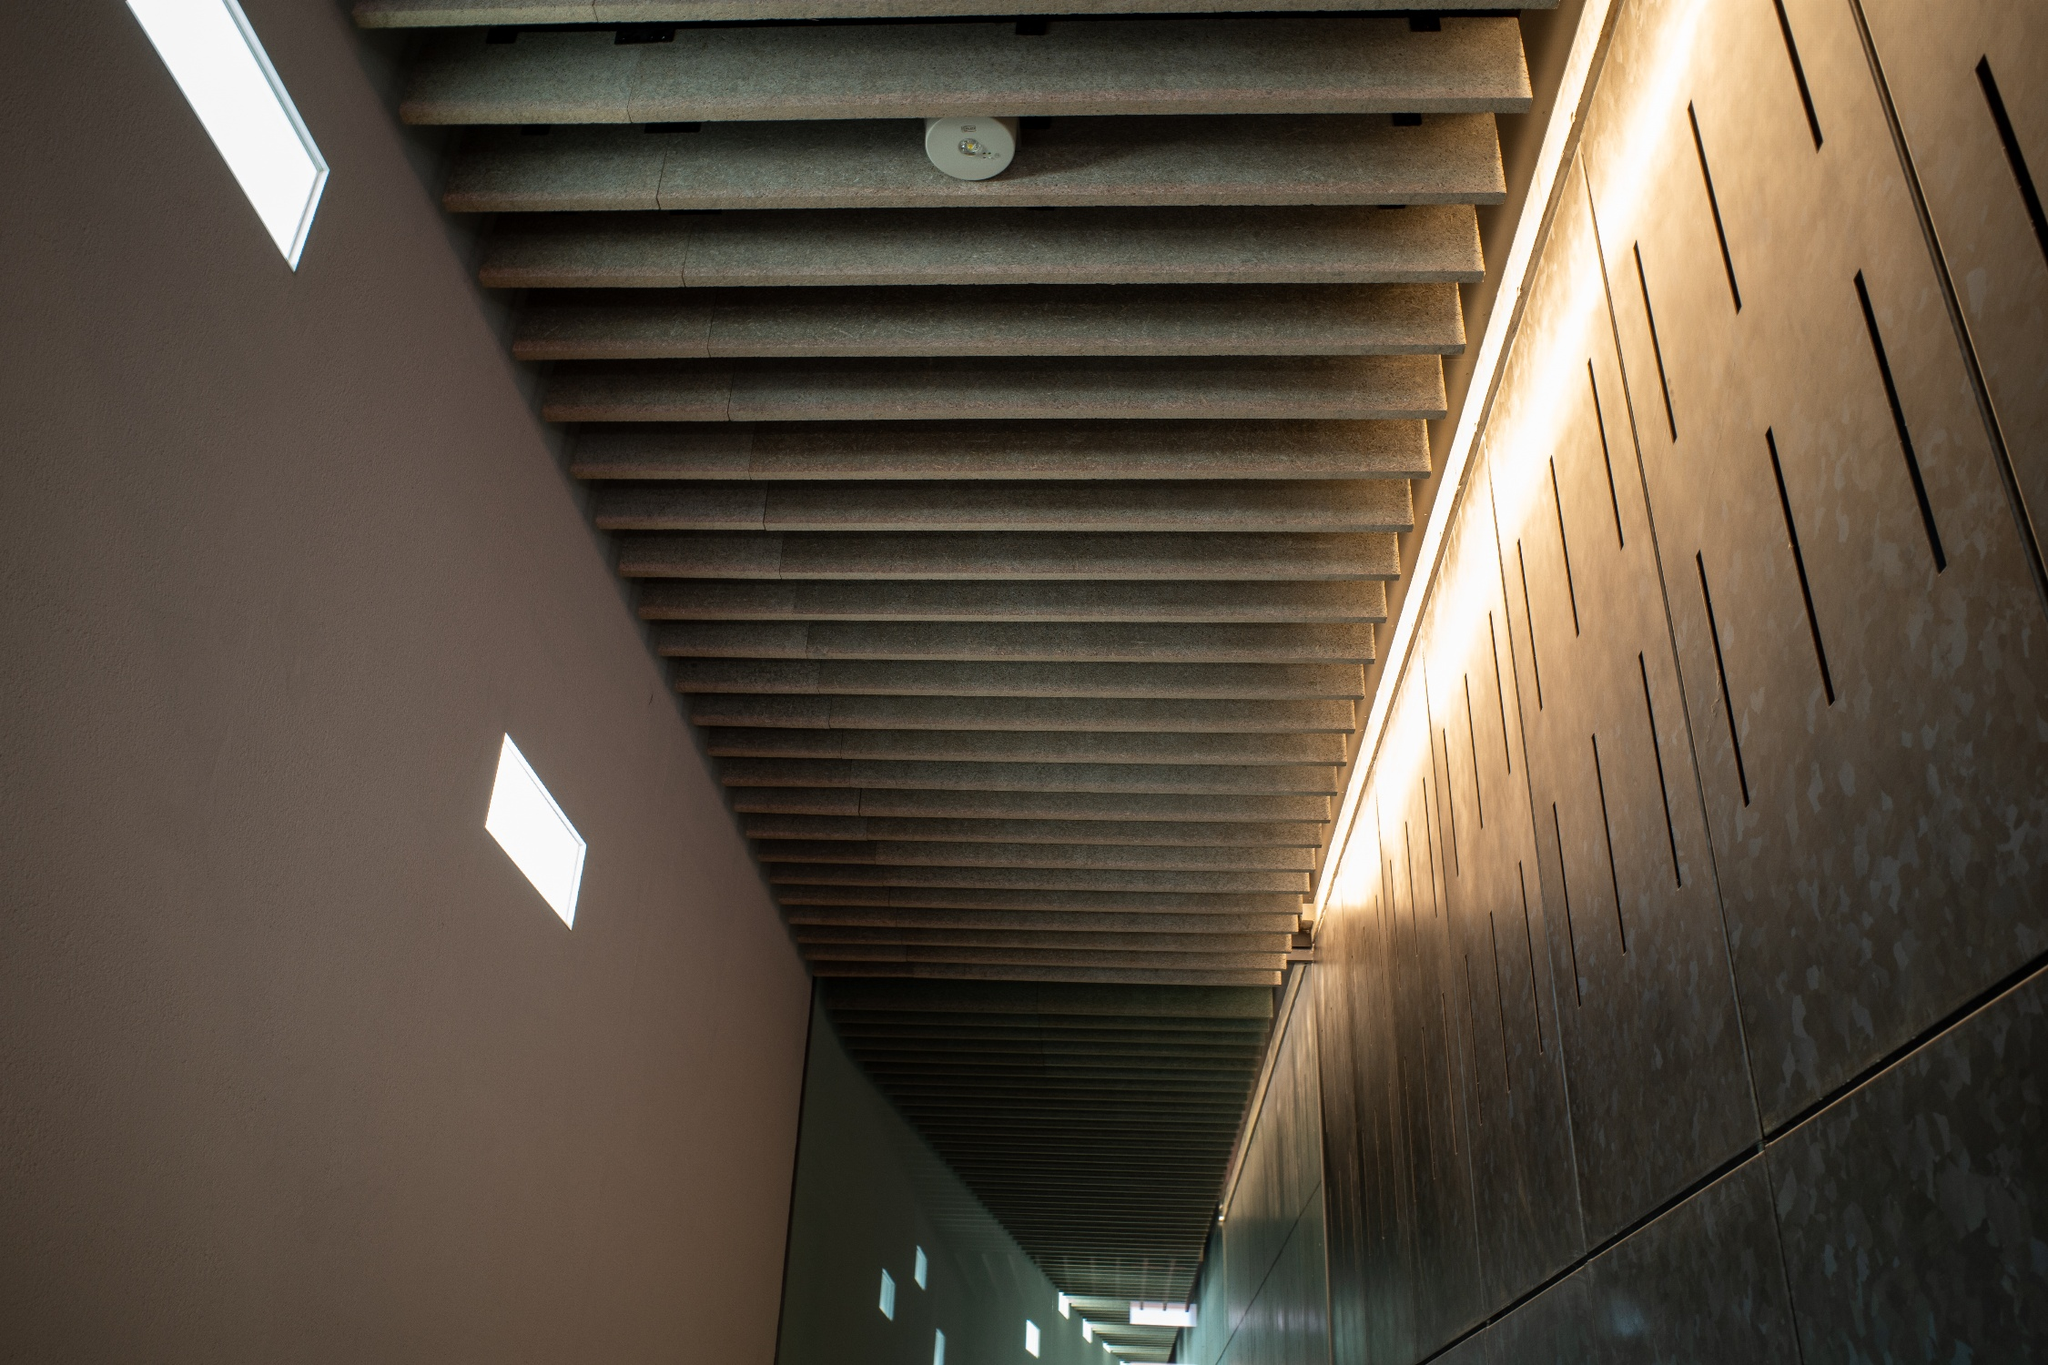Imagine this hallway in a dystopian science fiction setting. Describe it. In a dystopian future, this hallway is part of an underground bunker that serves as the last refuge for humanity. The once pristine and polished stones are now marked by the passage of time and the struggles of the inhabitants. The ribbed ceiling, now lined with makeshift lights and cables, hums faintly as the backup generators struggle to power the complex. The small rectangular windows, now repurposed as vigil slots, expose only the dark, desolate world outside. Despite the harsh reality, this hallway remains a symbol of hope, leading to a meeting room where plans for a brighter future are tirelessly discussed. 